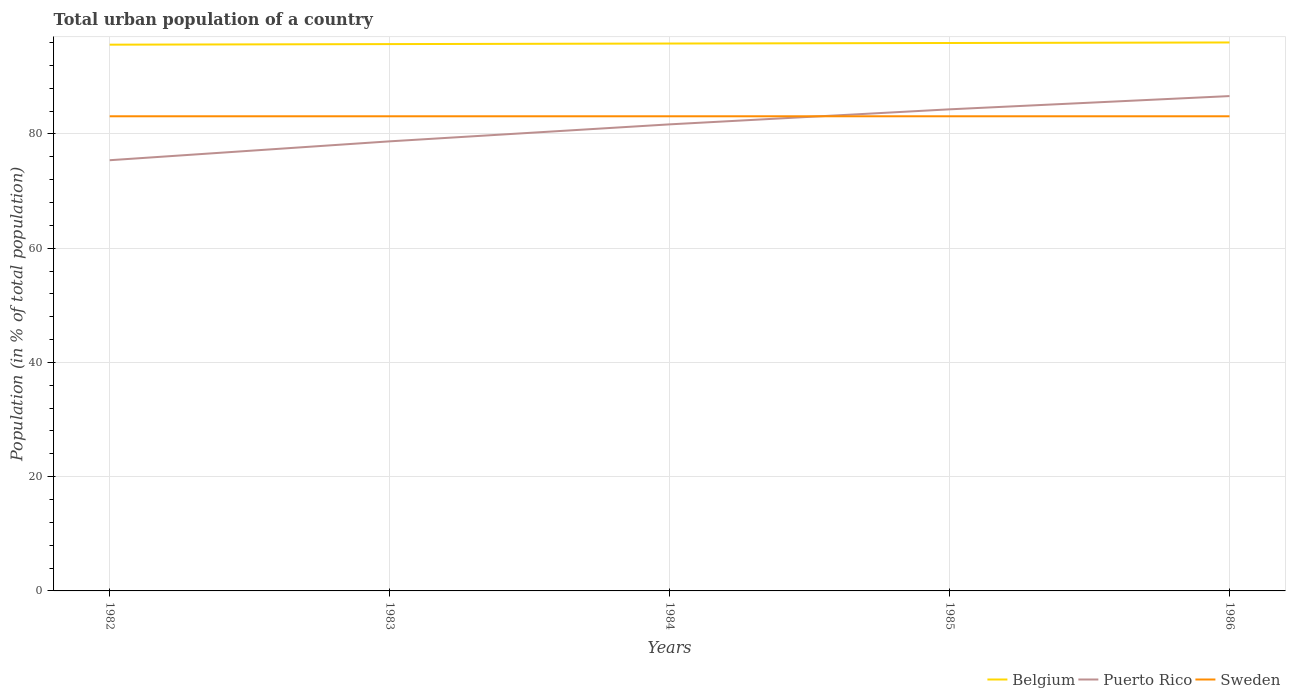Does the line corresponding to Puerto Rico intersect with the line corresponding to Belgium?
Provide a succinct answer. No. Across all years, what is the maximum urban population in Puerto Rico?
Your answer should be compact. 75.41. In which year was the urban population in Puerto Rico maximum?
Your answer should be very brief. 1982. What is the difference between the highest and the second highest urban population in Puerto Rico?
Your answer should be compact. 11.23. What is the difference between the highest and the lowest urban population in Puerto Rico?
Give a very brief answer. 3. How many lines are there?
Give a very brief answer. 3. How many years are there in the graph?
Provide a succinct answer. 5. What is the difference between two consecutive major ticks on the Y-axis?
Your answer should be compact. 20. Where does the legend appear in the graph?
Your response must be concise. Bottom right. How many legend labels are there?
Keep it short and to the point. 3. How are the legend labels stacked?
Your answer should be compact. Horizontal. What is the title of the graph?
Offer a terse response. Total urban population of a country. Does "Liberia" appear as one of the legend labels in the graph?
Keep it short and to the point. No. What is the label or title of the X-axis?
Ensure brevity in your answer.  Years. What is the label or title of the Y-axis?
Your response must be concise. Population (in % of total population). What is the Population (in % of total population) of Belgium in 1982?
Your answer should be compact. 95.64. What is the Population (in % of total population) in Puerto Rico in 1982?
Provide a succinct answer. 75.41. What is the Population (in % of total population) of Sweden in 1982?
Give a very brief answer. 83.1. What is the Population (in % of total population) in Belgium in 1983?
Your answer should be very brief. 95.74. What is the Population (in % of total population) in Puerto Rico in 1983?
Ensure brevity in your answer.  78.71. What is the Population (in % of total population) in Sweden in 1983?
Offer a very short reply. 83.1. What is the Population (in % of total population) in Belgium in 1984?
Provide a short and direct response. 95.83. What is the Population (in % of total population) of Puerto Rico in 1984?
Your response must be concise. 81.68. What is the Population (in % of total population) in Sweden in 1984?
Your response must be concise. 83.1. What is the Population (in % of total population) of Belgium in 1985?
Give a very brief answer. 95.93. What is the Population (in % of total population) of Puerto Rico in 1985?
Your answer should be very brief. 84.32. What is the Population (in % of total population) in Sweden in 1985?
Your answer should be very brief. 83.1. What is the Population (in % of total population) in Belgium in 1986?
Give a very brief answer. 96.02. What is the Population (in % of total population) in Puerto Rico in 1986?
Your answer should be very brief. 86.64. What is the Population (in % of total population) of Sweden in 1986?
Offer a very short reply. 83.1. Across all years, what is the maximum Population (in % of total population) of Belgium?
Ensure brevity in your answer.  96.02. Across all years, what is the maximum Population (in % of total population) of Puerto Rico?
Keep it short and to the point. 86.64. Across all years, what is the maximum Population (in % of total population) in Sweden?
Give a very brief answer. 83.1. Across all years, what is the minimum Population (in % of total population) in Belgium?
Provide a succinct answer. 95.64. Across all years, what is the minimum Population (in % of total population) in Puerto Rico?
Provide a succinct answer. 75.41. Across all years, what is the minimum Population (in % of total population) of Sweden?
Make the answer very short. 83.1. What is the total Population (in % of total population) of Belgium in the graph?
Your response must be concise. 479.16. What is the total Population (in % of total population) in Puerto Rico in the graph?
Offer a terse response. 406.75. What is the total Population (in % of total population) in Sweden in the graph?
Give a very brief answer. 415.5. What is the difference between the Population (in % of total population) of Puerto Rico in 1982 and that in 1983?
Keep it short and to the point. -3.31. What is the difference between the Population (in % of total population) in Sweden in 1982 and that in 1983?
Offer a terse response. 0. What is the difference between the Population (in % of total population) in Belgium in 1982 and that in 1984?
Ensure brevity in your answer.  -0.2. What is the difference between the Population (in % of total population) in Puerto Rico in 1982 and that in 1984?
Keep it short and to the point. -6.28. What is the difference between the Population (in % of total population) in Belgium in 1982 and that in 1985?
Ensure brevity in your answer.  -0.29. What is the difference between the Population (in % of total population) in Puerto Rico in 1982 and that in 1985?
Provide a succinct answer. -8.91. What is the difference between the Population (in % of total population) in Belgium in 1982 and that in 1986?
Give a very brief answer. -0.39. What is the difference between the Population (in % of total population) of Puerto Rico in 1982 and that in 1986?
Give a very brief answer. -11.23. What is the difference between the Population (in % of total population) of Belgium in 1983 and that in 1984?
Your response must be concise. -0.1. What is the difference between the Population (in % of total population) in Puerto Rico in 1983 and that in 1984?
Keep it short and to the point. -2.97. What is the difference between the Population (in % of total population) of Sweden in 1983 and that in 1984?
Make the answer very short. 0. What is the difference between the Population (in % of total population) in Belgium in 1983 and that in 1985?
Provide a short and direct response. -0.19. What is the difference between the Population (in % of total population) in Puerto Rico in 1983 and that in 1985?
Your response must be concise. -5.61. What is the difference between the Population (in % of total population) of Sweden in 1983 and that in 1985?
Give a very brief answer. 0. What is the difference between the Population (in % of total population) in Belgium in 1983 and that in 1986?
Provide a short and direct response. -0.29. What is the difference between the Population (in % of total population) of Puerto Rico in 1983 and that in 1986?
Make the answer very short. -7.93. What is the difference between the Population (in % of total population) of Sweden in 1983 and that in 1986?
Ensure brevity in your answer.  0. What is the difference between the Population (in % of total population) in Belgium in 1984 and that in 1985?
Your answer should be very brief. -0.1. What is the difference between the Population (in % of total population) of Puerto Rico in 1984 and that in 1985?
Provide a short and direct response. -2.63. What is the difference between the Population (in % of total population) of Belgium in 1984 and that in 1986?
Give a very brief answer. -0.19. What is the difference between the Population (in % of total population) of Puerto Rico in 1984 and that in 1986?
Provide a succinct answer. -4.95. What is the difference between the Population (in % of total population) in Sweden in 1984 and that in 1986?
Offer a very short reply. 0. What is the difference between the Population (in % of total population) in Belgium in 1985 and that in 1986?
Your response must be concise. -0.09. What is the difference between the Population (in % of total population) in Puerto Rico in 1985 and that in 1986?
Keep it short and to the point. -2.32. What is the difference between the Population (in % of total population) in Sweden in 1985 and that in 1986?
Offer a very short reply. 0. What is the difference between the Population (in % of total population) in Belgium in 1982 and the Population (in % of total population) in Puerto Rico in 1983?
Make the answer very short. 16.93. What is the difference between the Population (in % of total population) of Belgium in 1982 and the Population (in % of total population) of Sweden in 1983?
Give a very brief answer. 12.54. What is the difference between the Population (in % of total population) of Puerto Rico in 1982 and the Population (in % of total population) of Sweden in 1983?
Your response must be concise. -7.69. What is the difference between the Population (in % of total population) of Belgium in 1982 and the Population (in % of total population) of Puerto Rico in 1984?
Offer a very short reply. 13.95. What is the difference between the Population (in % of total population) in Belgium in 1982 and the Population (in % of total population) in Sweden in 1984?
Give a very brief answer. 12.54. What is the difference between the Population (in % of total population) of Puerto Rico in 1982 and the Population (in % of total population) of Sweden in 1984?
Ensure brevity in your answer.  -7.69. What is the difference between the Population (in % of total population) of Belgium in 1982 and the Population (in % of total population) of Puerto Rico in 1985?
Your answer should be compact. 11.32. What is the difference between the Population (in % of total population) in Belgium in 1982 and the Population (in % of total population) in Sweden in 1985?
Your answer should be very brief. 12.54. What is the difference between the Population (in % of total population) of Puerto Rico in 1982 and the Population (in % of total population) of Sweden in 1985?
Your answer should be very brief. -7.69. What is the difference between the Population (in % of total population) in Belgium in 1982 and the Population (in % of total population) in Sweden in 1986?
Provide a succinct answer. 12.54. What is the difference between the Population (in % of total population) in Puerto Rico in 1982 and the Population (in % of total population) in Sweden in 1986?
Your answer should be compact. -7.69. What is the difference between the Population (in % of total population) of Belgium in 1983 and the Population (in % of total population) of Puerto Rico in 1984?
Your answer should be very brief. 14.05. What is the difference between the Population (in % of total population) of Belgium in 1983 and the Population (in % of total population) of Sweden in 1984?
Your response must be concise. 12.64. What is the difference between the Population (in % of total population) of Puerto Rico in 1983 and the Population (in % of total population) of Sweden in 1984?
Provide a short and direct response. -4.39. What is the difference between the Population (in % of total population) of Belgium in 1983 and the Population (in % of total population) of Puerto Rico in 1985?
Ensure brevity in your answer.  11.42. What is the difference between the Population (in % of total population) of Belgium in 1983 and the Population (in % of total population) of Sweden in 1985?
Provide a succinct answer. 12.64. What is the difference between the Population (in % of total population) of Puerto Rico in 1983 and the Population (in % of total population) of Sweden in 1985?
Your answer should be very brief. -4.39. What is the difference between the Population (in % of total population) of Belgium in 1983 and the Population (in % of total population) of Sweden in 1986?
Give a very brief answer. 12.64. What is the difference between the Population (in % of total population) in Puerto Rico in 1983 and the Population (in % of total population) in Sweden in 1986?
Keep it short and to the point. -4.39. What is the difference between the Population (in % of total population) in Belgium in 1984 and the Population (in % of total population) in Puerto Rico in 1985?
Give a very brief answer. 11.52. What is the difference between the Population (in % of total population) of Belgium in 1984 and the Population (in % of total population) of Sweden in 1985?
Your response must be concise. 12.73. What is the difference between the Population (in % of total population) of Puerto Rico in 1984 and the Population (in % of total population) of Sweden in 1985?
Ensure brevity in your answer.  -1.42. What is the difference between the Population (in % of total population) in Belgium in 1984 and the Population (in % of total population) in Puerto Rico in 1986?
Your answer should be very brief. 9.2. What is the difference between the Population (in % of total population) in Belgium in 1984 and the Population (in % of total population) in Sweden in 1986?
Give a very brief answer. 12.73. What is the difference between the Population (in % of total population) in Puerto Rico in 1984 and the Population (in % of total population) in Sweden in 1986?
Your answer should be compact. -1.42. What is the difference between the Population (in % of total population) in Belgium in 1985 and the Population (in % of total population) in Puerto Rico in 1986?
Provide a succinct answer. 9.29. What is the difference between the Population (in % of total population) in Belgium in 1985 and the Population (in % of total population) in Sweden in 1986?
Provide a succinct answer. 12.83. What is the difference between the Population (in % of total population) in Puerto Rico in 1985 and the Population (in % of total population) in Sweden in 1986?
Make the answer very short. 1.22. What is the average Population (in % of total population) in Belgium per year?
Keep it short and to the point. 95.83. What is the average Population (in % of total population) in Puerto Rico per year?
Provide a succinct answer. 81.35. What is the average Population (in % of total population) of Sweden per year?
Your response must be concise. 83.1. In the year 1982, what is the difference between the Population (in % of total population) of Belgium and Population (in % of total population) of Puerto Rico?
Your response must be concise. 20.23. In the year 1982, what is the difference between the Population (in % of total population) in Belgium and Population (in % of total population) in Sweden?
Your answer should be compact. 12.54. In the year 1982, what is the difference between the Population (in % of total population) of Puerto Rico and Population (in % of total population) of Sweden?
Make the answer very short. -7.69. In the year 1983, what is the difference between the Population (in % of total population) in Belgium and Population (in % of total population) in Puerto Rico?
Keep it short and to the point. 17.03. In the year 1983, what is the difference between the Population (in % of total population) in Belgium and Population (in % of total population) in Sweden?
Ensure brevity in your answer.  12.64. In the year 1983, what is the difference between the Population (in % of total population) in Puerto Rico and Population (in % of total population) in Sweden?
Keep it short and to the point. -4.39. In the year 1984, what is the difference between the Population (in % of total population) of Belgium and Population (in % of total population) of Puerto Rico?
Offer a very short reply. 14.15. In the year 1984, what is the difference between the Population (in % of total population) of Belgium and Population (in % of total population) of Sweden?
Your answer should be compact. 12.73. In the year 1984, what is the difference between the Population (in % of total population) in Puerto Rico and Population (in % of total population) in Sweden?
Ensure brevity in your answer.  -1.42. In the year 1985, what is the difference between the Population (in % of total population) in Belgium and Population (in % of total population) in Puerto Rico?
Provide a short and direct response. 11.61. In the year 1985, what is the difference between the Population (in % of total population) of Belgium and Population (in % of total population) of Sweden?
Provide a succinct answer. 12.83. In the year 1985, what is the difference between the Population (in % of total population) in Puerto Rico and Population (in % of total population) in Sweden?
Keep it short and to the point. 1.22. In the year 1986, what is the difference between the Population (in % of total population) in Belgium and Population (in % of total population) in Puerto Rico?
Provide a succinct answer. 9.39. In the year 1986, what is the difference between the Population (in % of total population) of Belgium and Population (in % of total population) of Sweden?
Your response must be concise. 12.92. In the year 1986, what is the difference between the Population (in % of total population) of Puerto Rico and Population (in % of total population) of Sweden?
Provide a succinct answer. 3.54. What is the ratio of the Population (in % of total population) in Puerto Rico in 1982 to that in 1983?
Make the answer very short. 0.96. What is the ratio of the Population (in % of total population) of Sweden in 1982 to that in 1983?
Ensure brevity in your answer.  1. What is the ratio of the Population (in % of total population) in Sweden in 1982 to that in 1984?
Your answer should be very brief. 1. What is the ratio of the Population (in % of total population) in Belgium in 1982 to that in 1985?
Provide a succinct answer. 1. What is the ratio of the Population (in % of total population) of Puerto Rico in 1982 to that in 1985?
Offer a very short reply. 0.89. What is the ratio of the Population (in % of total population) in Sweden in 1982 to that in 1985?
Provide a succinct answer. 1. What is the ratio of the Population (in % of total population) in Puerto Rico in 1982 to that in 1986?
Ensure brevity in your answer.  0.87. What is the ratio of the Population (in % of total population) of Belgium in 1983 to that in 1984?
Offer a very short reply. 1. What is the ratio of the Population (in % of total population) of Puerto Rico in 1983 to that in 1984?
Offer a terse response. 0.96. What is the ratio of the Population (in % of total population) of Sweden in 1983 to that in 1984?
Offer a very short reply. 1. What is the ratio of the Population (in % of total population) in Belgium in 1983 to that in 1985?
Keep it short and to the point. 1. What is the ratio of the Population (in % of total population) of Puerto Rico in 1983 to that in 1985?
Provide a short and direct response. 0.93. What is the ratio of the Population (in % of total population) in Sweden in 1983 to that in 1985?
Offer a terse response. 1. What is the ratio of the Population (in % of total population) of Puerto Rico in 1983 to that in 1986?
Make the answer very short. 0.91. What is the ratio of the Population (in % of total population) in Sweden in 1983 to that in 1986?
Provide a short and direct response. 1. What is the ratio of the Population (in % of total population) in Puerto Rico in 1984 to that in 1985?
Your answer should be very brief. 0.97. What is the ratio of the Population (in % of total population) in Belgium in 1984 to that in 1986?
Make the answer very short. 1. What is the ratio of the Population (in % of total population) of Puerto Rico in 1984 to that in 1986?
Your answer should be very brief. 0.94. What is the ratio of the Population (in % of total population) of Sweden in 1984 to that in 1986?
Your answer should be compact. 1. What is the ratio of the Population (in % of total population) of Belgium in 1985 to that in 1986?
Keep it short and to the point. 1. What is the ratio of the Population (in % of total population) in Puerto Rico in 1985 to that in 1986?
Offer a terse response. 0.97. What is the difference between the highest and the second highest Population (in % of total population) in Belgium?
Your answer should be compact. 0.09. What is the difference between the highest and the second highest Population (in % of total population) of Puerto Rico?
Offer a very short reply. 2.32. What is the difference between the highest and the lowest Population (in % of total population) in Belgium?
Offer a very short reply. 0.39. What is the difference between the highest and the lowest Population (in % of total population) of Puerto Rico?
Make the answer very short. 11.23. 